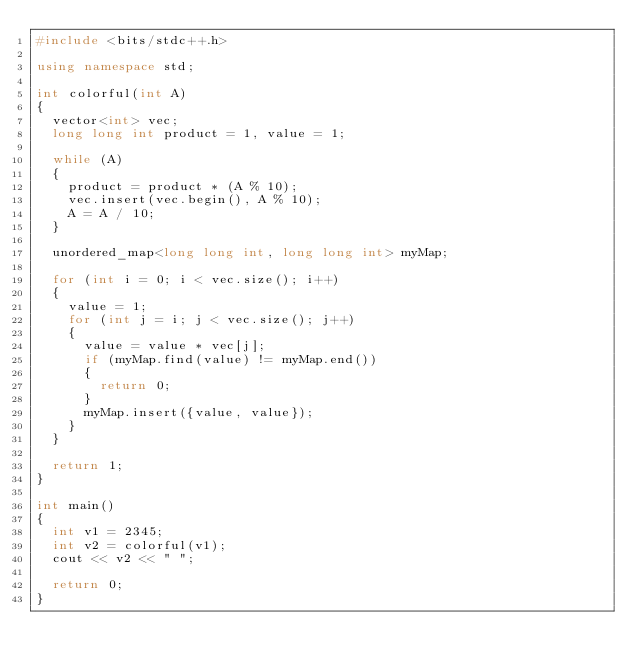<code> <loc_0><loc_0><loc_500><loc_500><_C++_>#include <bits/stdc++.h>

using namespace std;

int colorful(int A)
{
  vector<int> vec;
  long long int product = 1, value = 1;

  while (A)
  {
    product = product * (A % 10);
    vec.insert(vec.begin(), A % 10);
    A = A / 10;
  }

  unordered_map<long long int, long long int> myMap;

  for (int i = 0; i < vec.size(); i++)
  {
    value = 1;
    for (int j = i; j < vec.size(); j++)
    {
      value = value * vec[j];
      if (myMap.find(value) != myMap.end())
      {
        return 0;
      }
      myMap.insert({value, value});
    }
  }

  return 1;
}

int main()
{
  int v1 = 2345;
  int v2 = colorful(v1);
  cout << v2 << " ";

  return 0;
}
</code> 